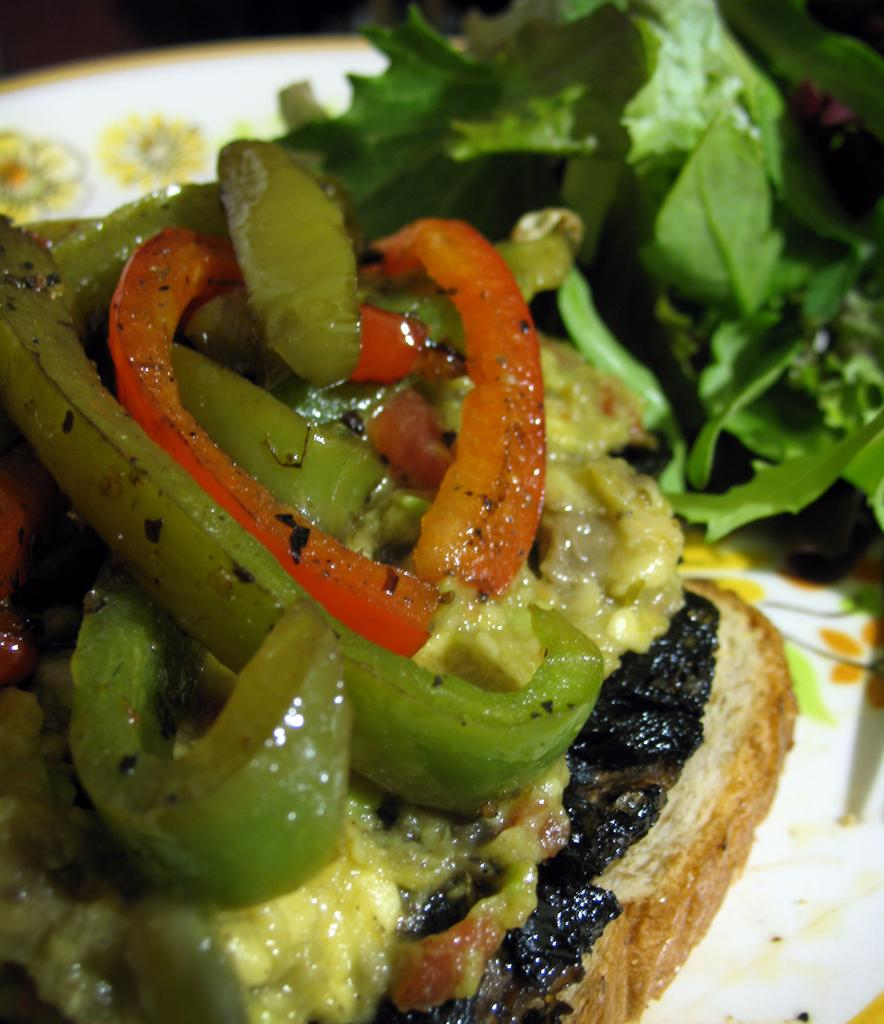What is present in the image? There are food items in the image. How are the food items arranged or contained? The food items are in a plate. What type of cracker is being delivered by the farmer in the image? There is no farmer or cracker present in the image; it only features food items in a plate. 